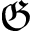<formula> <loc_0><loc_0><loc_500><loc_500>\mathfrak { G }</formula> 